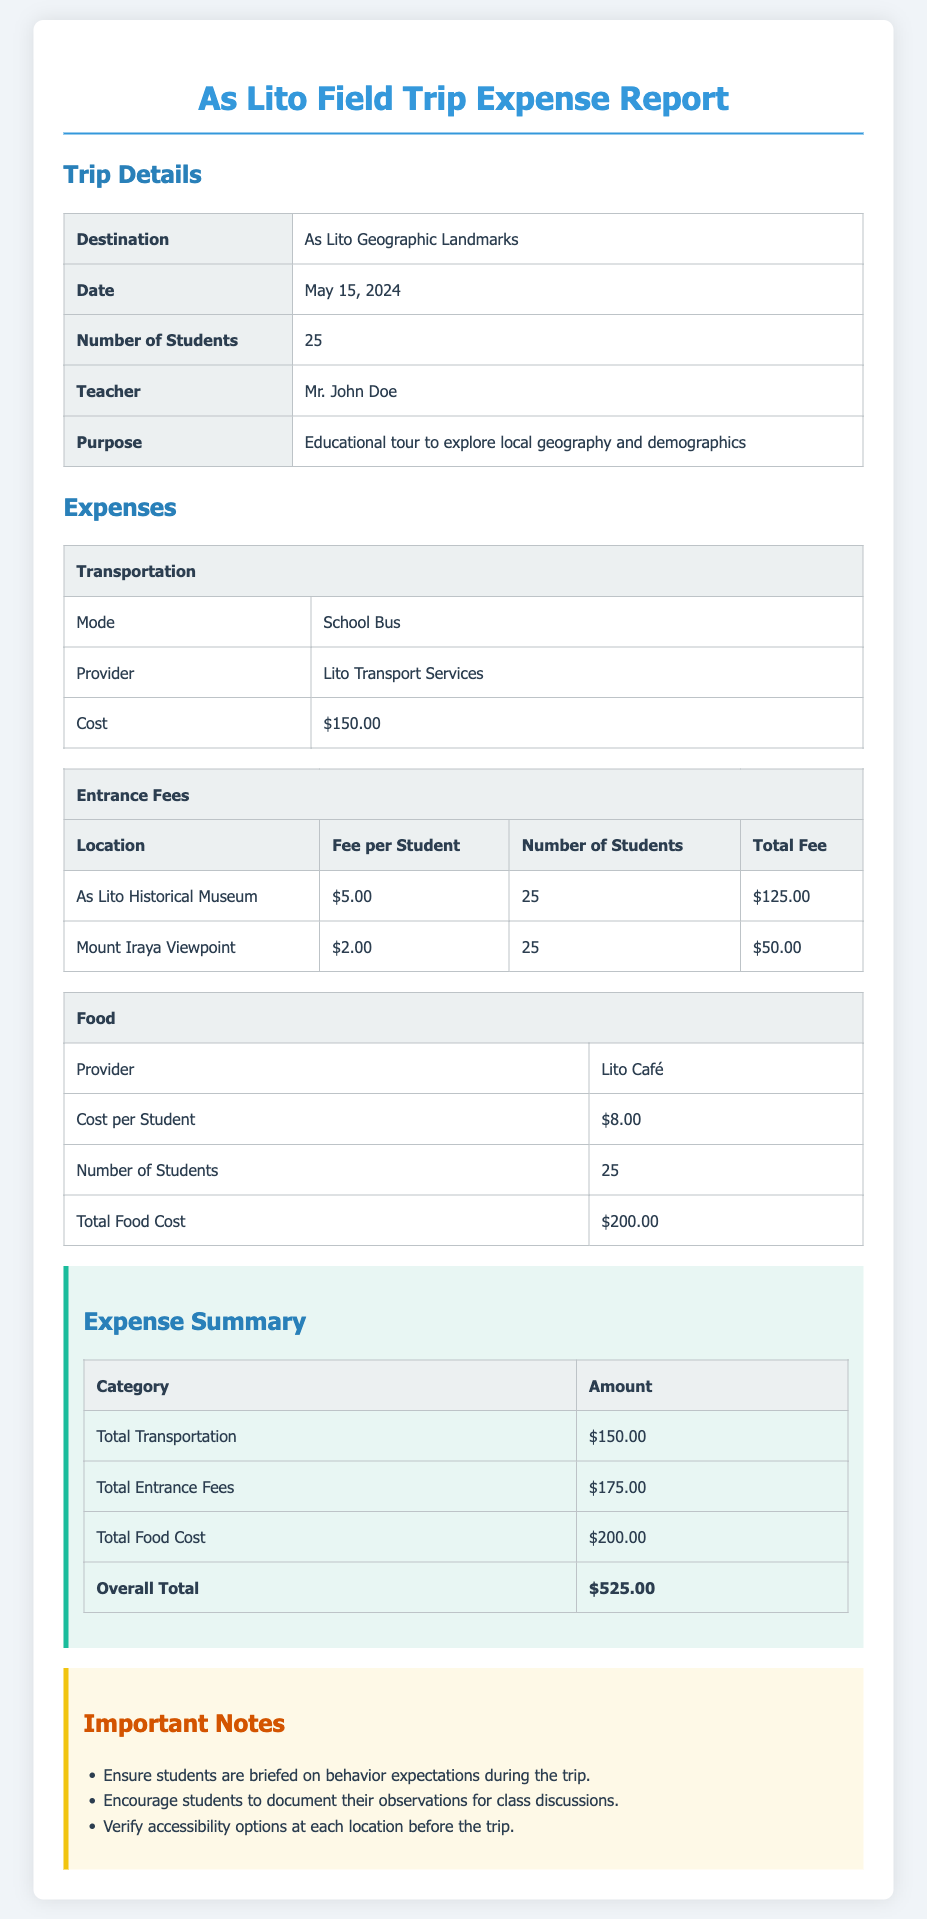What is the purpose of the field trip? The purpose of the field trip is stated as an educational tour to explore local geography and demographics.
Answer: Educational tour to explore local geography and demographics What is the total cost for food? The total food cost is given in the expenses section as $200.00.
Answer: $200.00 How many students are participating in the trip? The document specifies that the number of students is 25.
Answer: 25 Who is the teacher in charge of the field trip? The name of the teacher is provided in the trip details as Mr. John Doe.
Answer: Mr. John Doe What is the entrance fee per student for the As Lito Historical Museum? The document states that the entrance fee per student for the museum is $5.00.
Answer: $5.00 What is the overall total expense for the trip? The overall total is calculated in the expense summary as $525.00.
Answer: $525.00 What mode of transportation was used for the trip? The transportation mode used for the trip is a School Bus, as outlined in the transportation table.
Answer: School Bus What important note emphasizes student behavior during the trip? One of the important notes advises that students should be briefed on behavior expectations during the trip.
Answer: Ensure students are briefed on behavior expectations during the trip What is the cost of the entrance fee per student for Mount Iraya Viewpoint? The fee per student for Mount Iraya Viewpoint is listed as $2.00 in the entrance fees table.
Answer: $2.00 